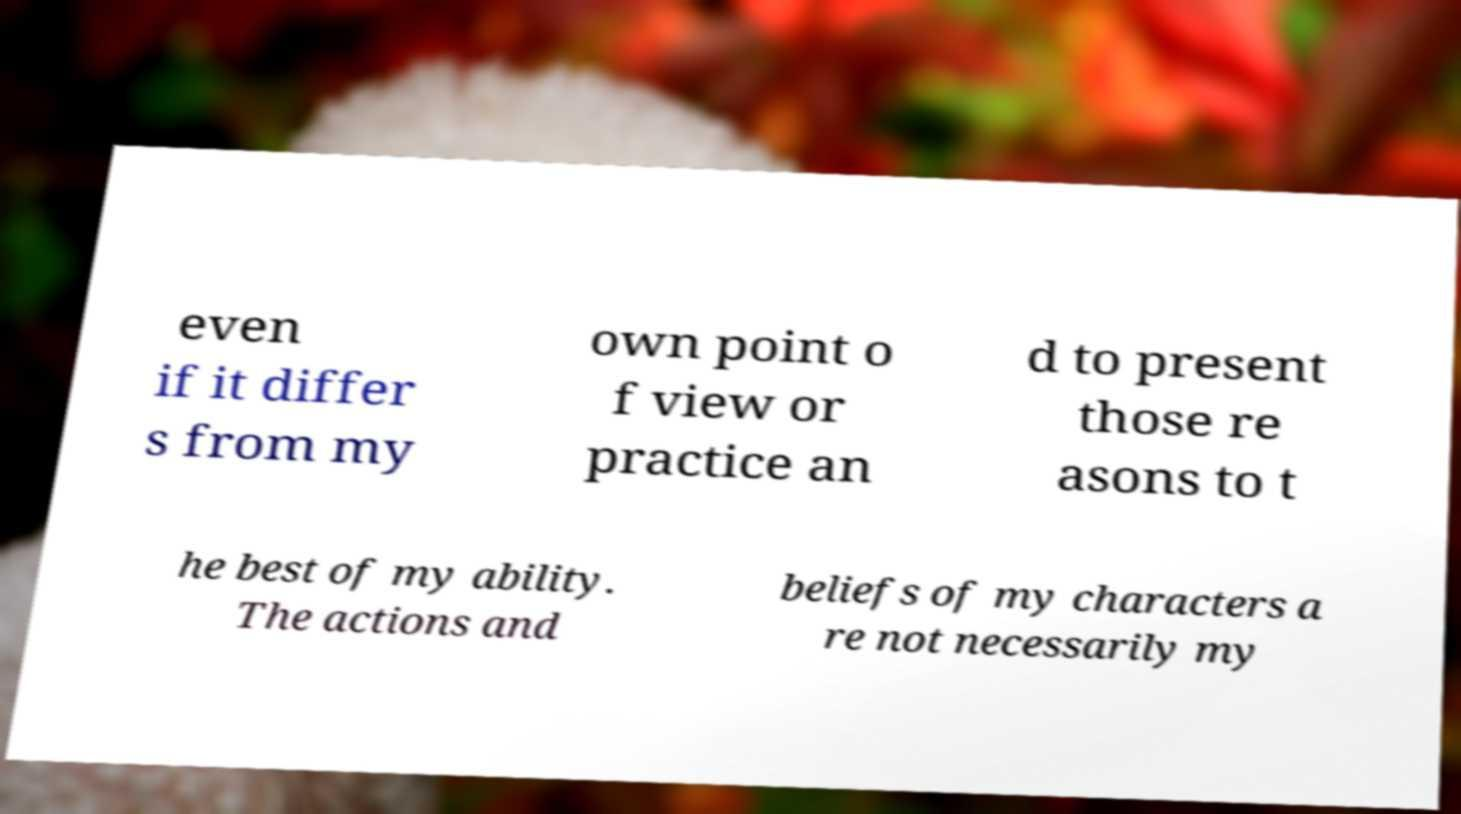There's text embedded in this image that I need extracted. Can you transcribe it verbatim? even if it differ s from my own point o f view or practice an d to present those re asons to t he best of my ability. The actions and beliefs of my characters a re not necessarily my 